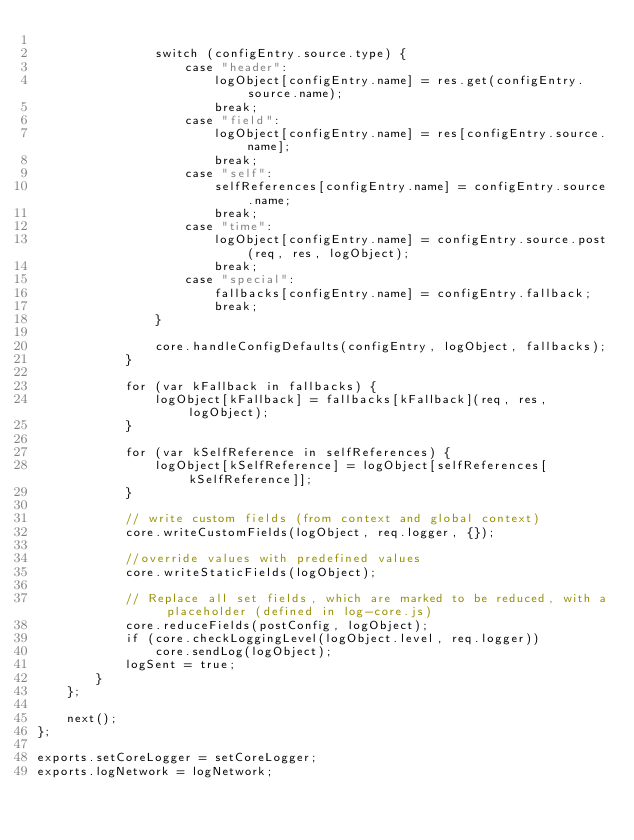Convert code to text. <code><loc_0><loc_0><loc_500><loc_500><_JavaScript_>
                switch (configEntry.source.type) {
                    case "header":
                        logObject[configEntry.name] = res.get(configEntry.source.name);
                        break;
                    case "field":
                        logObject[configEntry.name] = res[configEntry.source.name];
                        break;
                    case "self":
                        selfReferences[configEntry.name] = configEntry.source.name;
                        break;
                    case "time":
                        logObject[configEntry.name] = configEntry.source.post(req, res, logObject);
                        break;
                    case "special":
                        fallbacks[configEntry.name] = configEntry.fallback;
                        break;
                }

                core.handleConfigDefaults(configEntry, logObject, fallbacks);
            }

            for (var kFallback in fallbacks) {
                logObject[kFallback] = fallbacks[kFallback](req, res, logObject);
            }

            for (var kSelfReference in selfReferences) {
                logObject[kSelfReference] = logObject[selfReferences[kSelfReference]];
            }

            // write custom fields (from context and global context)
            core.writeCustomFields(logObject, req.logger, {});

            //override values with predefined values
            core.writeStaticFields(logObject);

            // Replace all set fields, which are marked to be reduced, with a placeholder (defined in log-core.js)
            core.reduceFields(postConfig, logObject);
            if (core.checkLoggingLevel(logObject.level, req.logger))
                core.sendLog(logObject);
            logSent = true;
        }
    };

    next();
};

exports.setCoreLogger = setCoreLogger;
exports.logNetwork = logNetwork;</code> 